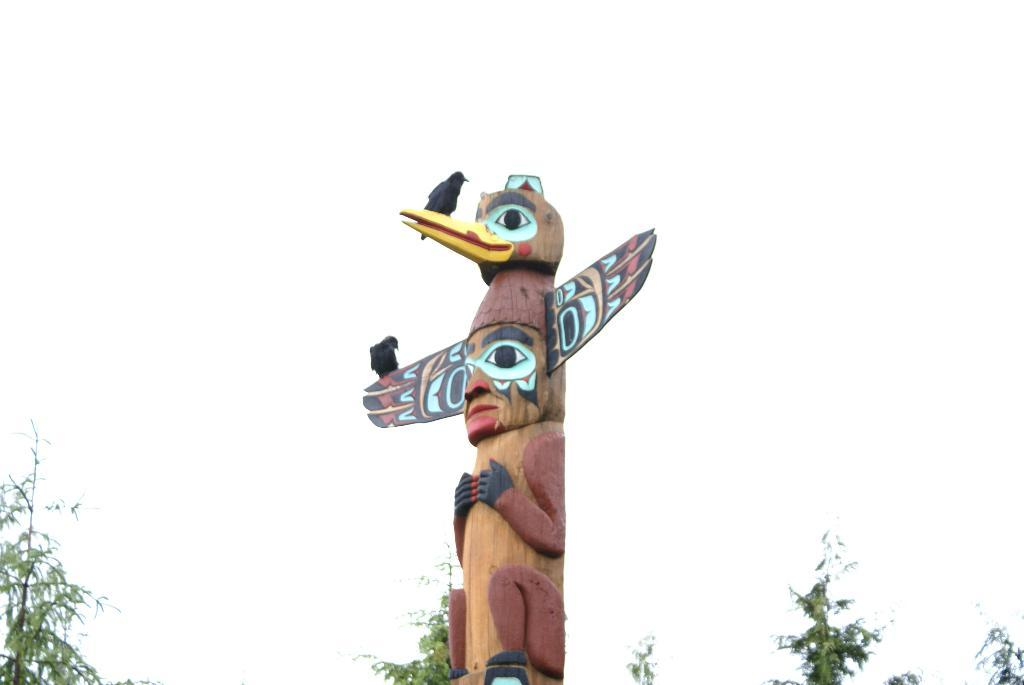What is the main subject in the image? There is a statue in the image. Are there any animals on the statue? Yes, there are two birds on the statue. What type of natural environment is visible in the image? There are trees visible in the image. What can be seen in the background of the image? The sky is visible in the background of the image. What type of wave is depicted in the image? There is no wave present in the image; it features a statue with birds and a natural environment with trees and the sky. 